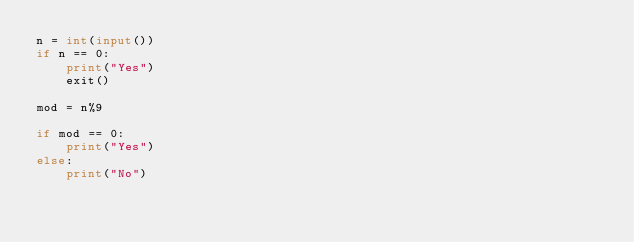Convert code to text. <code><loc_0><loc_0><loc_500><loc_500><_Python_>n = int(input())
if n == 0:
    print("Yes")
    exit()

mod = n%9

if mod == 0:
    print("Yes")
else:
    print("No")</code> 